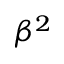<formula> <loc_0><loc_0><loc_500><loc_500>\beta ^ { 2 }</formula> 